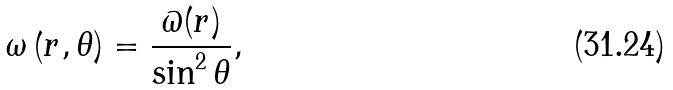<formula> <loc_0><loc_0><loc_500><loc_500>\omega \left ( r , \theta \right ) = \frac { \varpi ( r ) } { \sin ^ { 2 } \theta } ,</formula> 